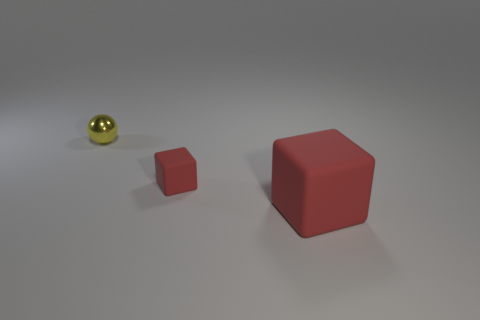Is there anything else that has the same material as the sphere? Based on the image, it's not possible to conclusively determine the material composition of the objects. The sphere appears to be shiny and reflective, which might suggest a metal or polished finish, while the other objects lack this characteristic sheen. Therefore, we cannot say they are made of the same material solely based on visual assessment. 